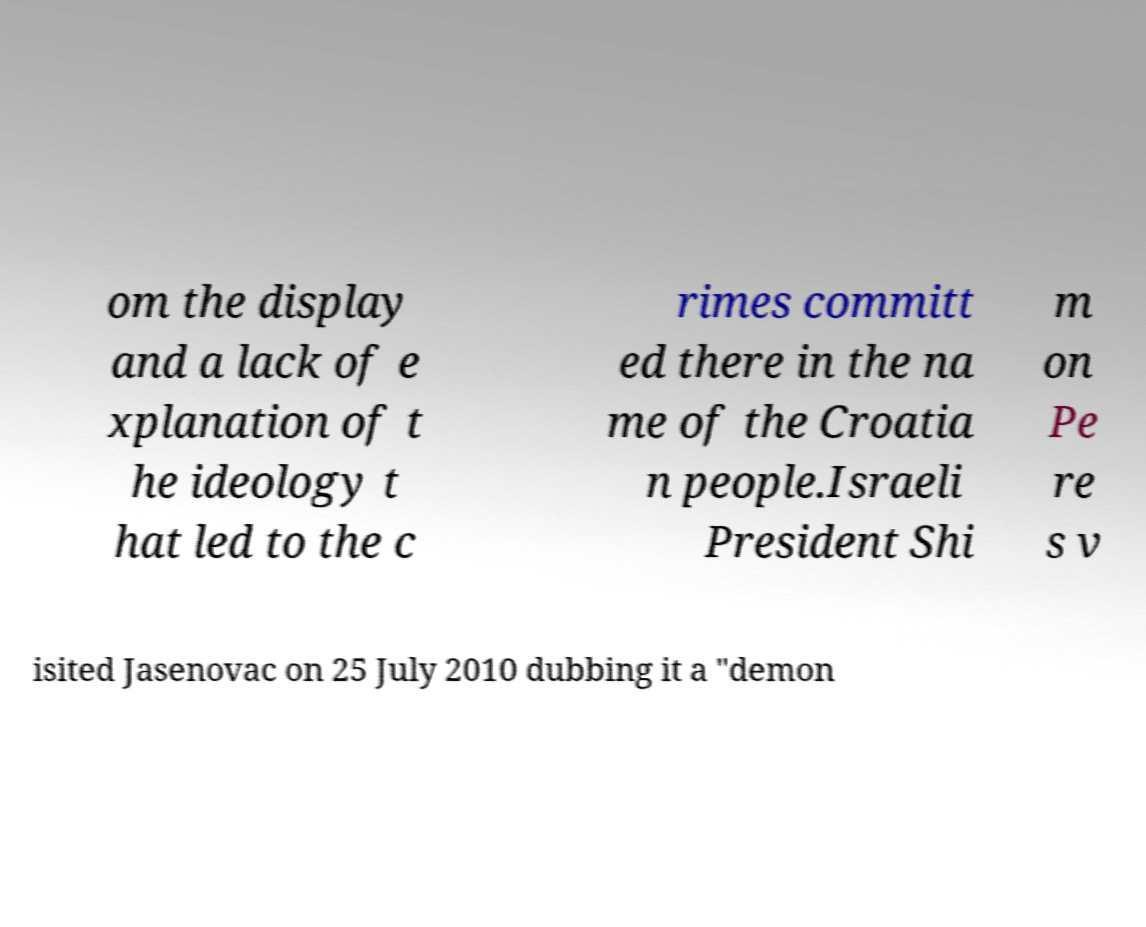Please read and relay the text visible in this image. What does it say? om the display and a lack of e xplanation of t he ideology t hat led to the c rimes committ ed there in the na me of the Croatia n people.Israeli President Shi m on Pe re s v isited Jasenovac on 25 July 2010 dubbing it a "demon 